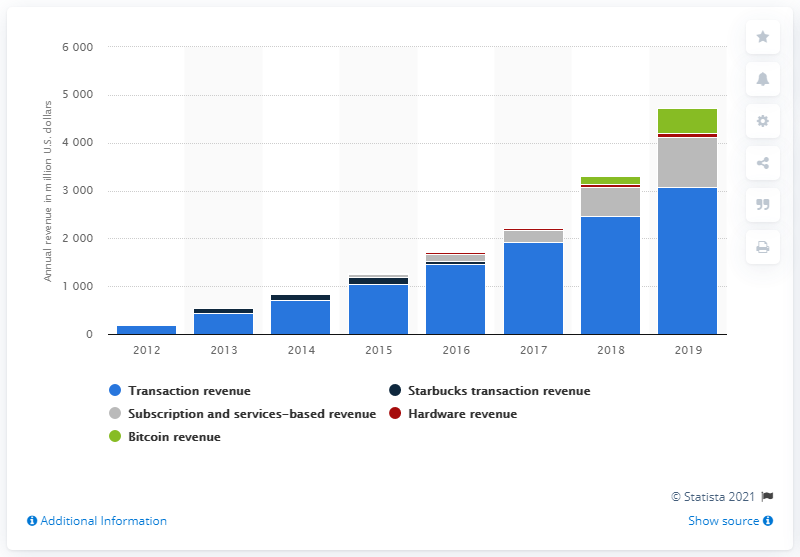Highlight a few significant elements in this photo. In the previous year, Square's net transaction revenues were 2,471.45. Square's net transaction revenues in the most recent fiscal period were $3081.07. 